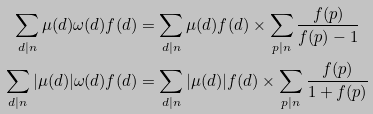Convert formula to latex. <formula><loc_0><loc_0><loc_500><loc_500>\sum _ { d | n } \mu ( d ) \omega ( d ) f ( d ) & = \sum _ { d | n } \mu ( d ) f ( d ) \times \sum _ { p | n } \frac { f ( p ) } { f ( p ) - 1 } \\ \sum _ { d | n } | \mu ( d ) | \omega ( d ) f ( d ) & = \sum _ { d | n } | \mu ( d ) | f ( d ) \times \sum _ { p | n } \frac { f ( p ) } { 1 + f ( p ) }</formula> 